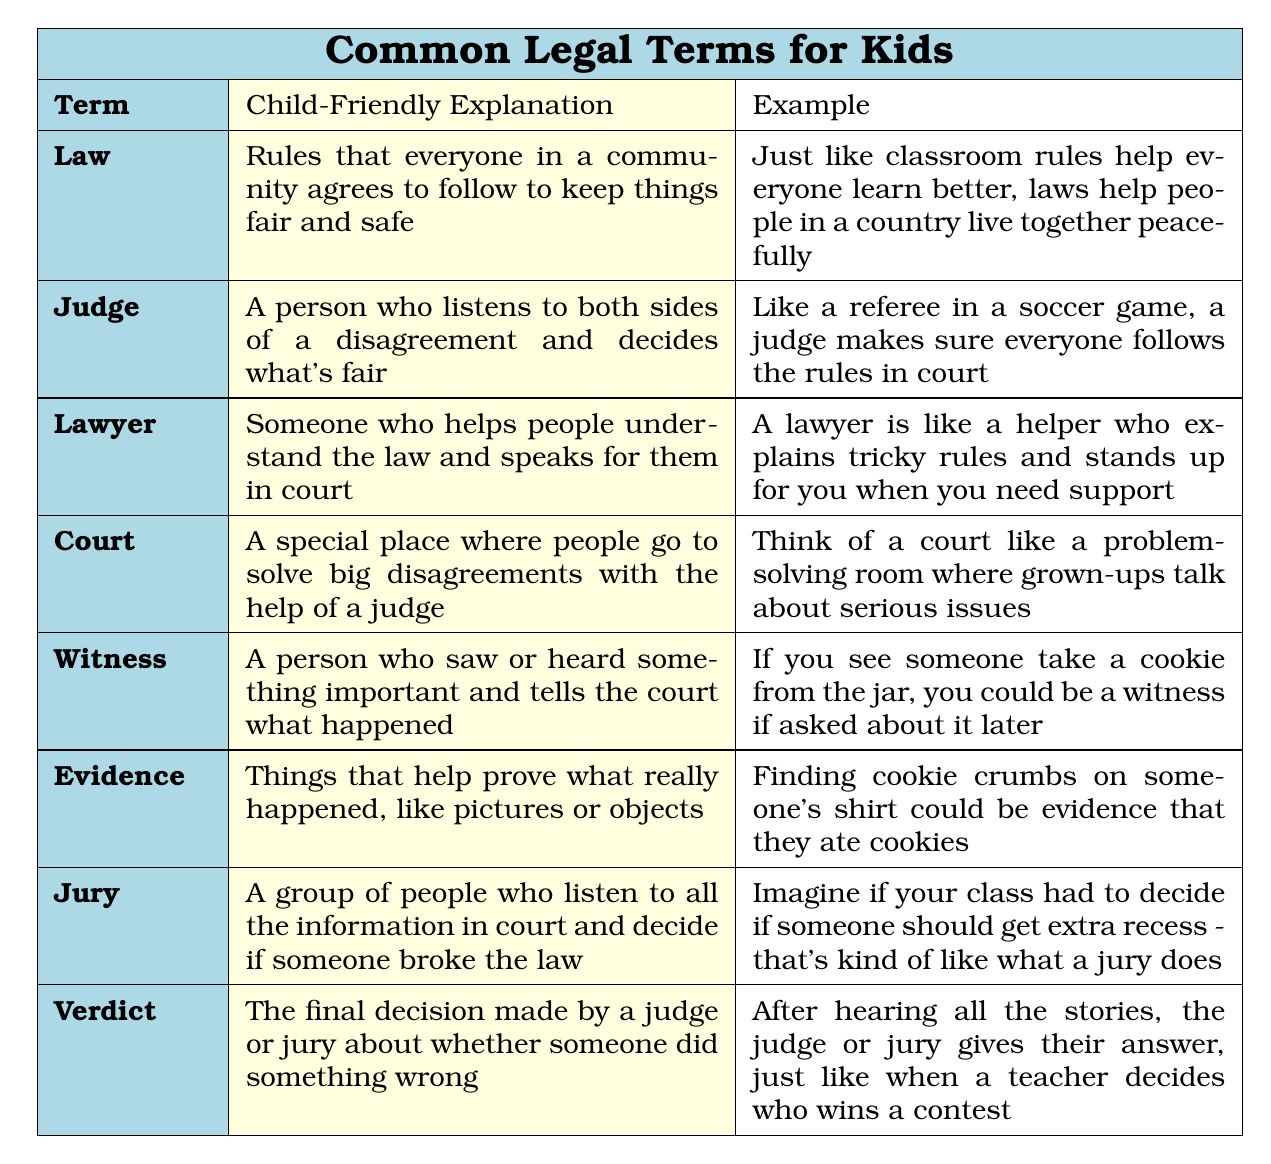What is the child-friendly explanation of "Law"? The explanation is found in the row under "Law," which states it is "Rules that everyone in a community agrees to follow to keep things fair and safe."
Answer: Rules that everyone agrees to follow What example is provided for a "Judge"? The example in the row for "Judge" is "Like a referee in a soccer game, a judge makes sure everyone follows the rules in court."
Answer: Like a referee in a soccer game How many terms are defined in the table? There are 8 terms listed in the table, as counted from each row under the "Term" column.
Answer: 8 Is a "Lawyer" someone who helps people understand the law? Yes, the explanation for "Lawyer" explicitly states that they help people understand the law and speaks for them in court.
Answer: Yes Which term has an example related to cookies? The term "Evidence" has the example about finding cookie crumbs on someone's shirt.
Answer: Evidence What is a "Verdict"? The table describes a "Verdict" as the final decision made by a judge or jury about whether someone did something wrong.
Answer: Final decision on wrongdoing If a "Witness" saw someone take a cookie, what could they do? The explanation for "Witness" suggests they could tell the court what happened, as they have seen something important.
Answer: Tell the court what happened Compare "Judge" and "Jury". How are their roles similar? Both "Judge" and "Jury" are involved in listening to information, but a judge decides what's fair while a jury decides if someone broke the law. They both make important decisions in court.
Answer: They both make important decisions in court What would a child understand about the role of a "Lawyer"? A child would learn that a lawyer is someone who explains tricky rules and stands up for you in court, acting like a helper.
Answer: A helper who explains rules and stands up for you 